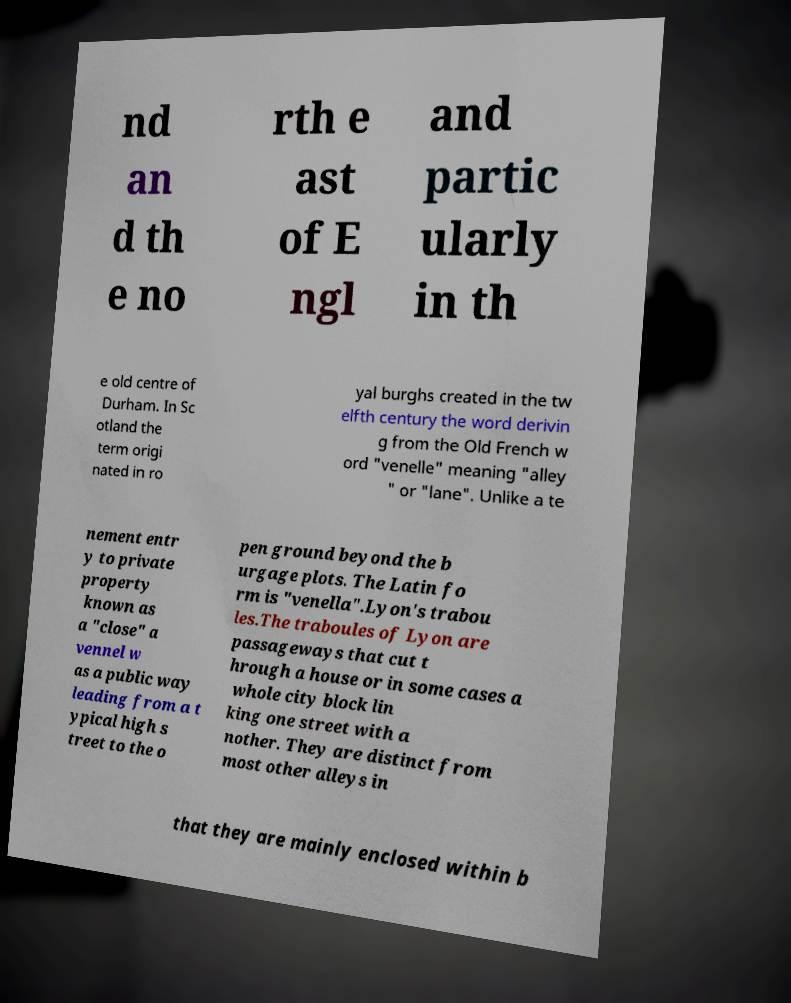There's text embedded in this image that I need extracted. Can you transcribe it verbatim? nd an d th e no rth e ast of E ngl and partic ularly in th e old centre of Durham. In Sc otland the term origi nated in ro yal burghs created in the tw elfth century the word derivin g from the Old French w ord "venelle" meaning "alley " or "lane". Unlike a te nement entr y to private property known as a "close" a vennel w as a public way leading from a t ypical high s treet to the o pen ground beyond the b urgage plots. The Latin fo rm is "venella".Lyon's trabou les.The traboules of Lyon are passageways that cut t hrough a house or in some cases a whole city block lin king one street with a nother. They are distinct from most other alleys in that they are mainly enclosed within b 